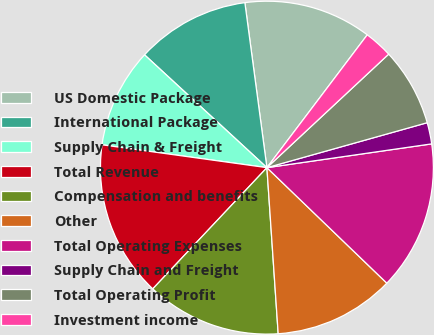<chart> <loc_0><loc_0><loc_500><loc_500><pie_chart><fcel>US Domestic Package<fcel>International Package<fcel>Supply Chain & Freight<fcel>Total Revenue<fcel>Compensation and benefits<fcel>Other<fcel>Total Operating Expenses<fcel>Supply Chain and Freight<fcel>Total Operating Profit<fcel>Investment income<nl><fcel>12.41%<fcel>11.03%<fcel>9.66%<fcel>15.17%<fcel>13.1%<fcel>11.72%<fcel>14.48%<fcel>2.07%<fcel>7.59%<fcel>2.76%<nl></chart> 